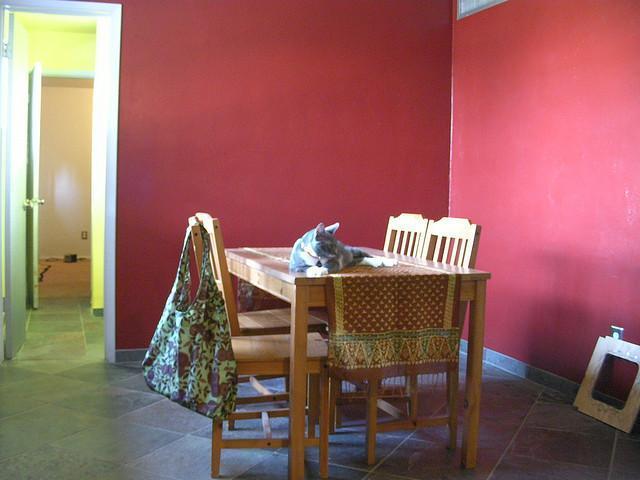How many chair legs are visible?
Give a very brief answer. 8. How many chairs are there?
Give a very brief answer. 2. How many giraffe heads can you see?
Give a very brief answer. 0. 